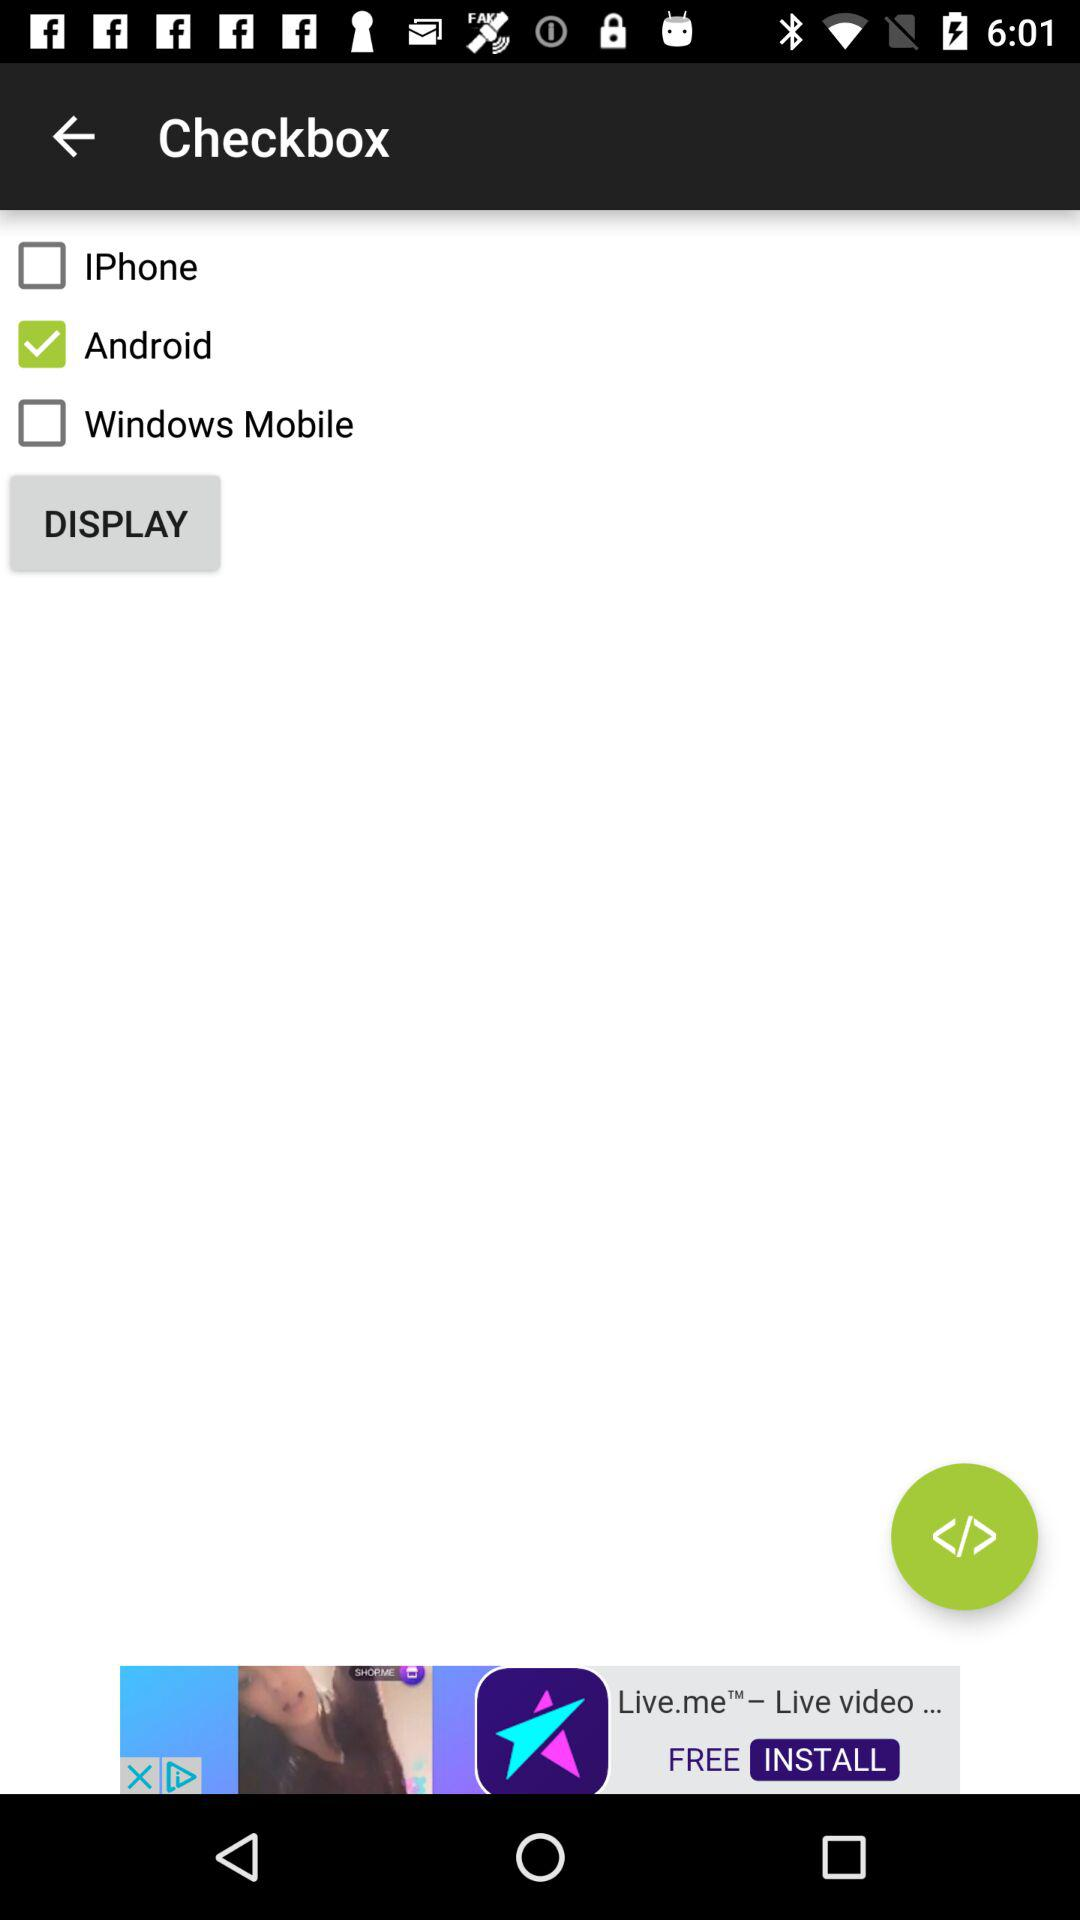How many checkboxes are unchecked?
Answer the question using a single word or phrase. 2 